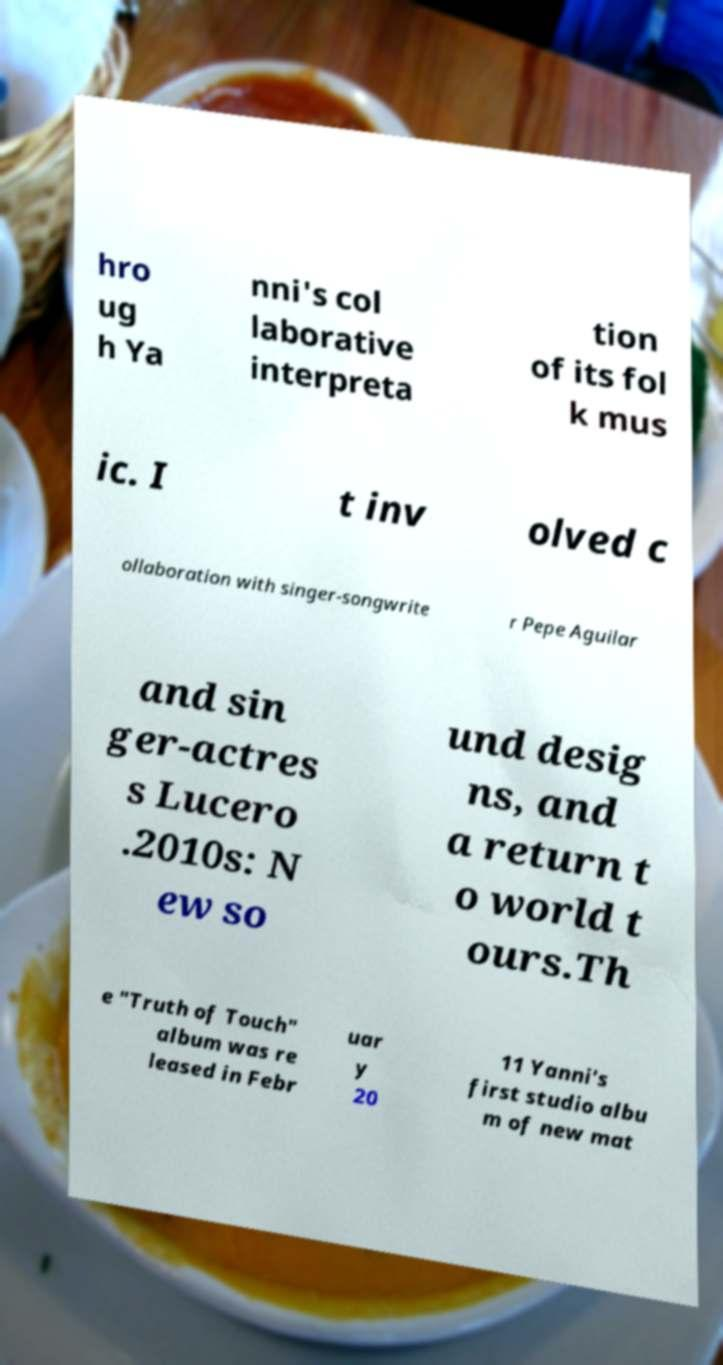For documentation purposes, I need the text within this image transcribed. Could you provide that? hro ug h Ya nni's col laborative interpreta tion of its fol k mus ic. I t inv olved c ollaboration with singer-songwrite r Pepe Aguilar and sin ger-actres s Lucero .2010s: N ew so und desig ns, and a return t o world t ours.Th e "Truth of Touch" album was re leased in Febr uar y 20 11 Yanni's first studio albu m of new mat 